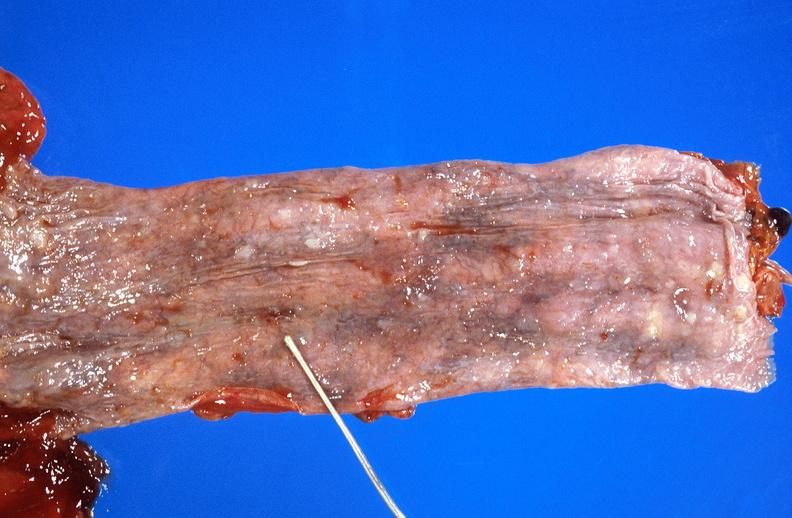where does this belong to?
Answer the question using a single word or phrase. Gastrointestinal system 